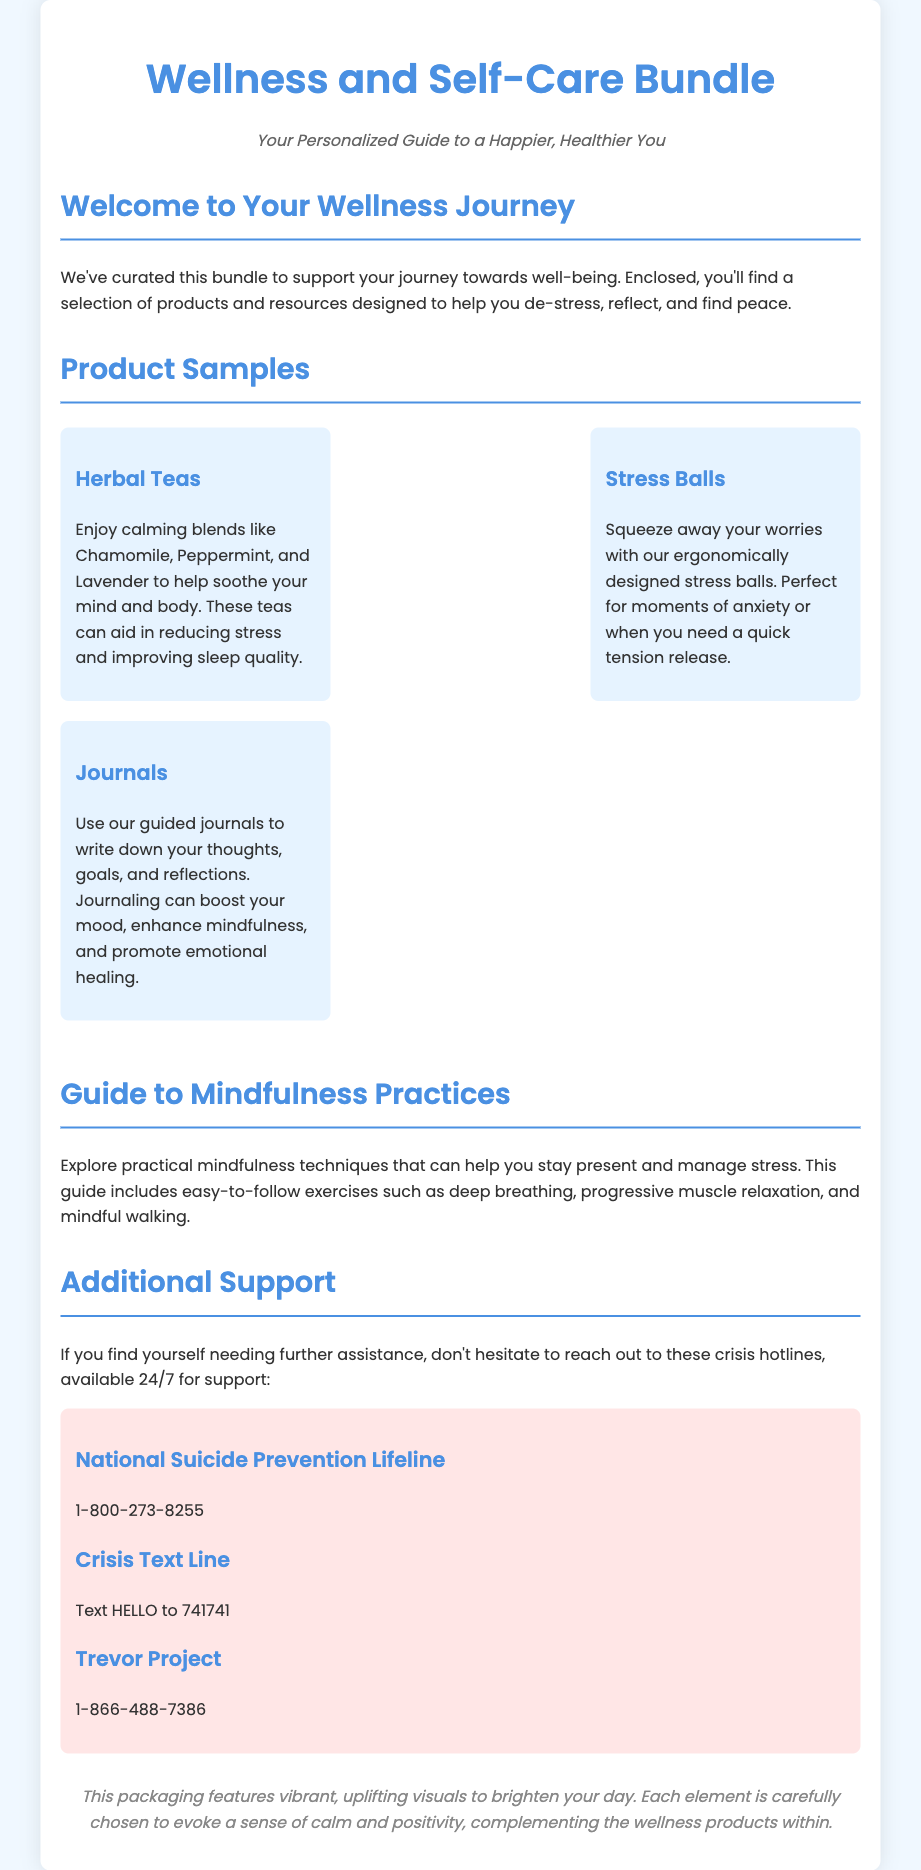What is included in the wellness bundle? The wellness bundle includes herbal teas, stress balls, journals, and a guide to mindfulness practices.
Answer: Herbal teas, stress balls, journals, guide to mindfulness practices What type of teas are provided? The document mentions calming blends such as Chamomile, Peppermint, and Lavender.
Answer: Chamomile, Peppermint, Lavender What is the purpose of the journals? The journals are designed to help write thoughts, goals, and reflections, promoting emotional healing and mindfulness.
Answer: Boost mood, enhance mindfulness, promote emotional healing How many crisis hotlines are listed? The document lists three crisis hotlines for support.
Answer: Three What is the hotline number for the National Suicide Prevention Lifeline? The hotline number for the National Suicide Prevention Lifeline is explicitly mentioned in the document.
Answer: 1-800-273-8255 What design theme is used for the packaging? The packaging features vibrant and uplifting visuals aimed at brightening the day.
Answer: Vibrant, uplifting visuals What mindfulness techniques are included in the guide? The guide includes exercises such as deep breathing, progressive muscle relaxation, and mindful walking.
Answer: Deep breathing, progressive muscle relaxation, mindful walking What does the packaging aim to evoke? The design elements of the packaging aim to evoke a sense of calm and positivity.
Answer: Calm and positivity 